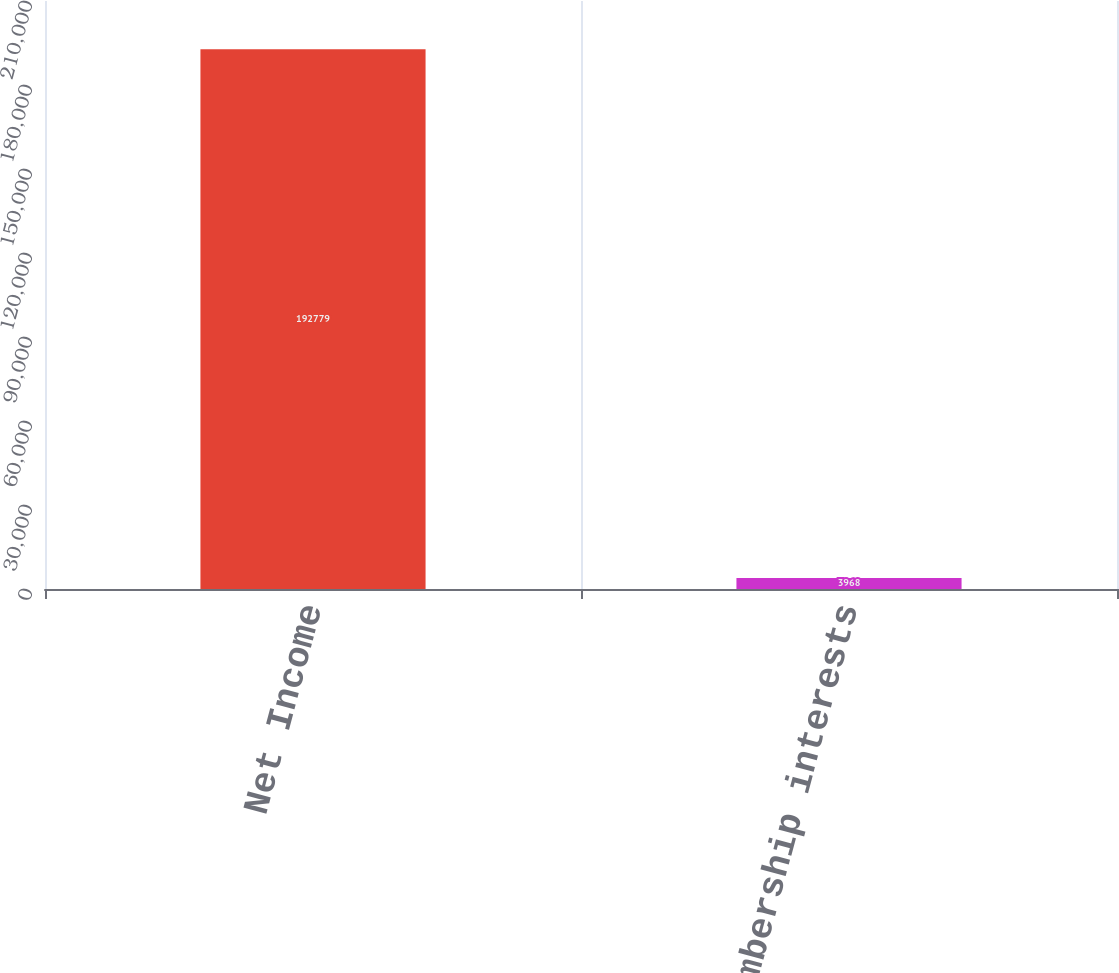<chart> <loc_0><loc_0><loc_500><loc_500><bar_chart><fcel>Net Income<fcel>Preferred membership interests<nl><fcel>192779<fcel>3968<nl></chart> 